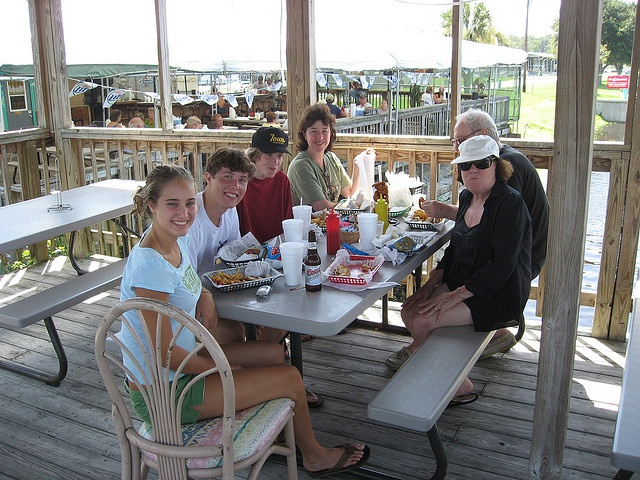Describe the objects in this image and their specific colors. I can see people in white, gray, maroon, black, and brown tones, chair in white, gray, and black tones, dining table in white, gray, darkgray, and black tones, people in white, black, and gray tones, and bench in white, gray, and black tones in this image. 